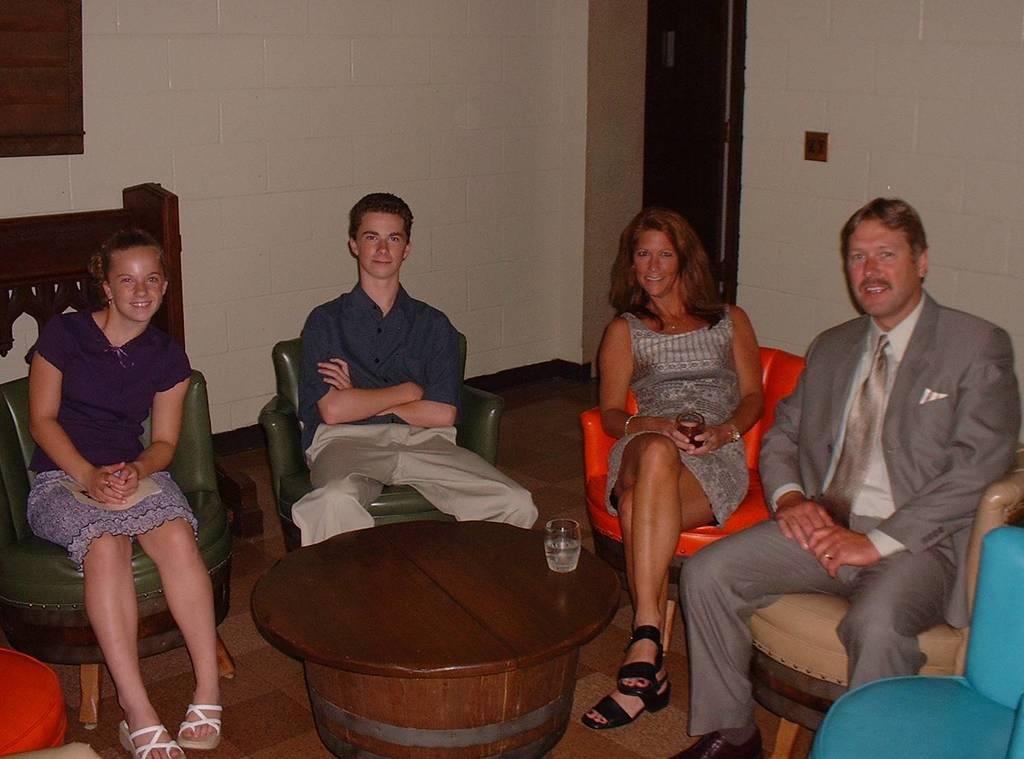How many people are present in the image? There are four people in the image. What are the people doing in the image? The people are sitting on a sofa and smiling. What can be seen in the center of the image? There is a wooden table in the center of the image. What is on the table? There is a glass on the table. What finger is the mother using to answer the phone in the image? There is no mother or phone present in the image. 